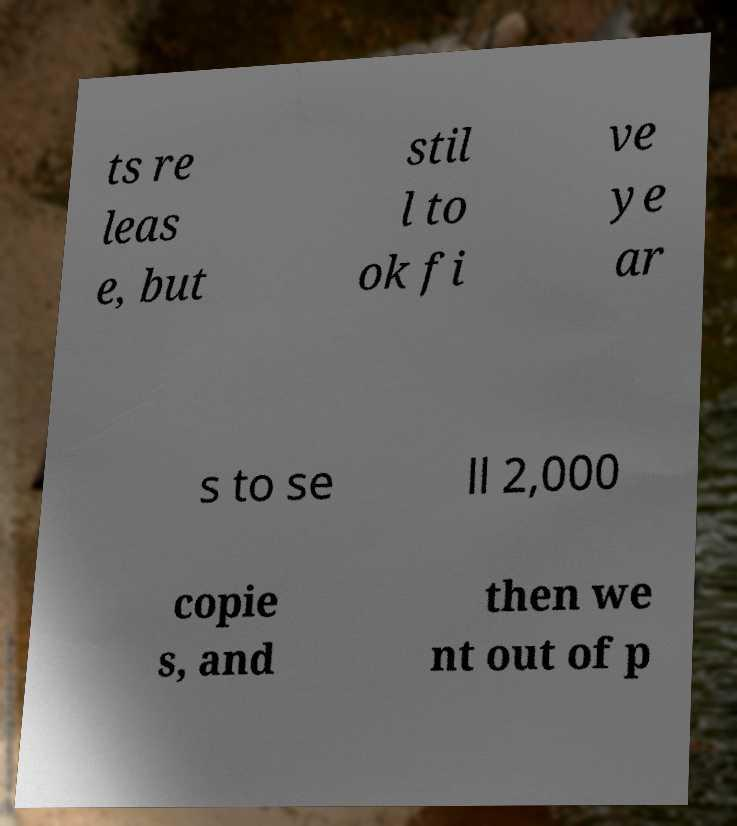Could you extract and type out the text from this image? ts re leas e, but stil l to ok fi ve ye ar s to se ll 2,000 copie s, and then we nt out of p 